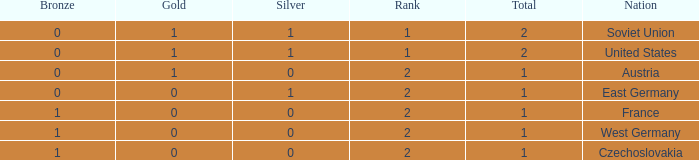What is the total number of bronze medals of West Germany, which is ranked 2 and has less than 1 total medals? 0.0. 